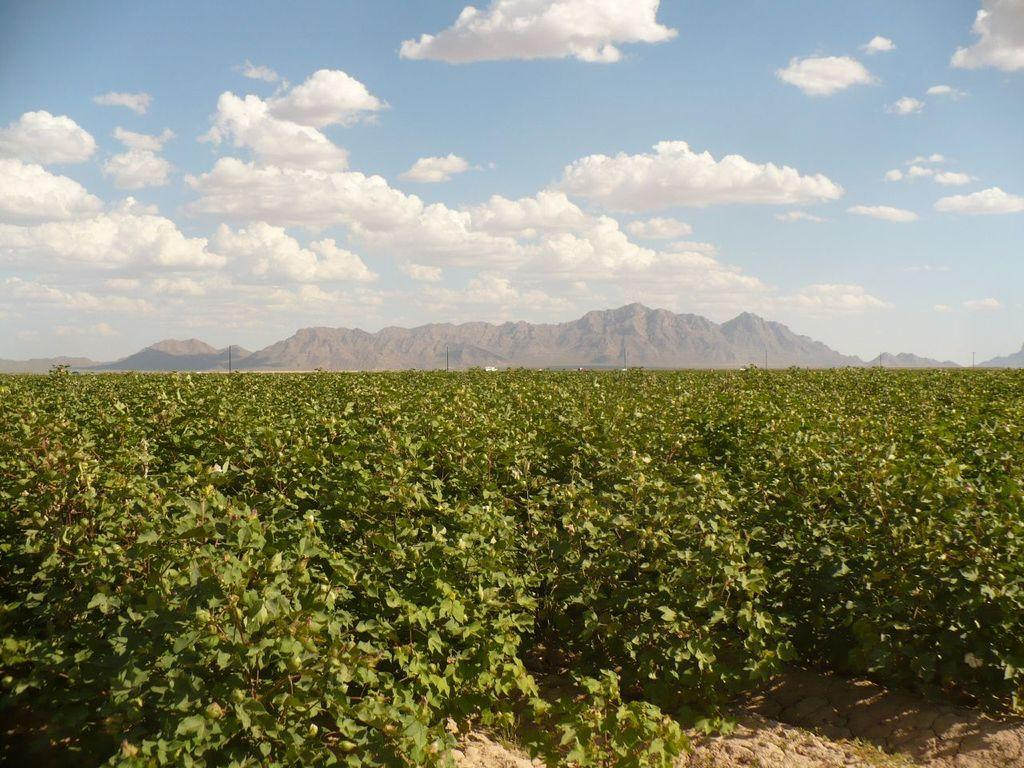What type of vegetation is present on the land in the image? There are plants on the land in the image. What can be seen in the distance behind the plants? There are hills visible in the background of the image. What is visible in the sky in the background of the image? There are clouds in the sky in the background of the image. What type of pies can be seen in the image? There are no pies present in the image; it features plants on the land, hills in the background, and clouds in the sky. 